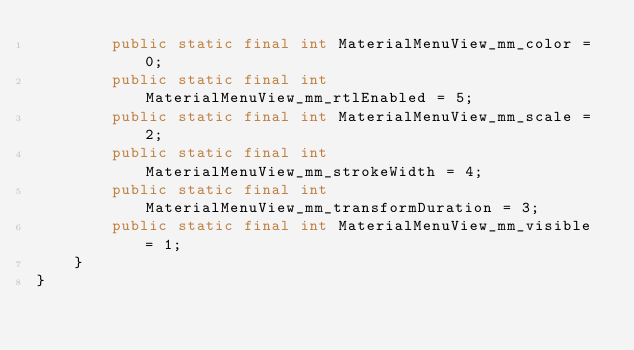<code> <loc_0><loc_0><loc_500><loc_500><_Java_>        public static final int MaterialMenuView_mm_color = 0;
        public static final int MaterialMenuView_mm_rtlEnabled = 5;
        public static final int MaterialMenuView_mm_scale = 2;
        public static final int MaterialMenuView_mm_strokeWidth = 4;
        public static final int MaterialMenuView_mm_transformDuration = 3;
        public static final int MaterialMenuView_mm_visible = 1;
    }
}
</code> 